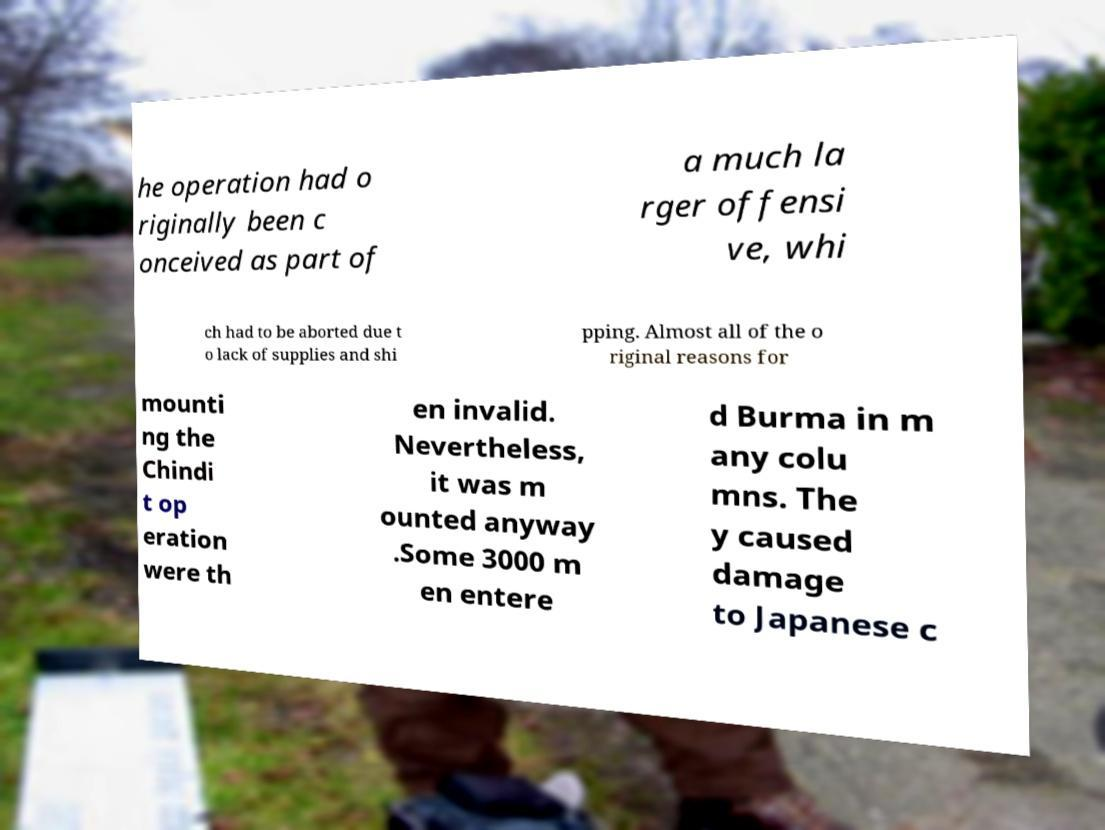Could you extract and type out the text from this image? he operation had o riginally been c onceived as part of a much la rger offensi ve, whi ch had to be aborted due t o lack of supplies and shi pping. Almost all of the o riginal reasons for mounti ng the Chindi t op eration were th en invalid. Nevertheless, it was m ounted anyway .Some 3000 m en entere d Burma in m any colu mns. The y caused damage to Japanese c 